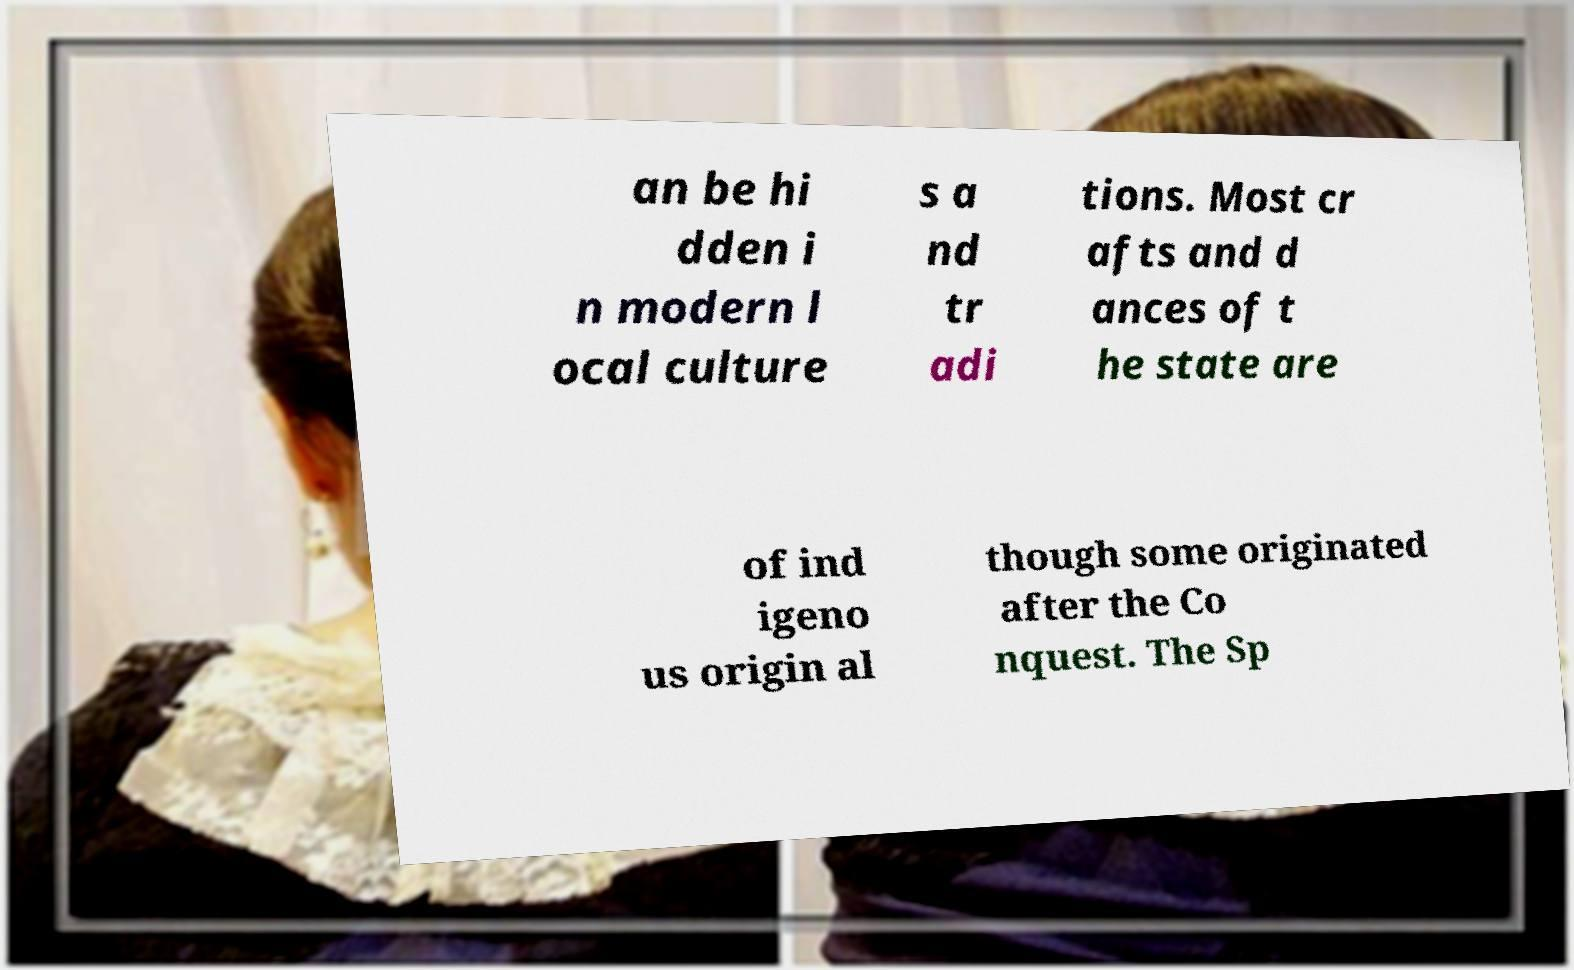Could you assist in decoding the text presented in this image and type it out clearly? an be hi dden i n modern l ocal culture s a nd tr adi tions. Most cr afts and d ances of t he state are of ind igeno us origin al though some originated after the Co nquest. The Sp 